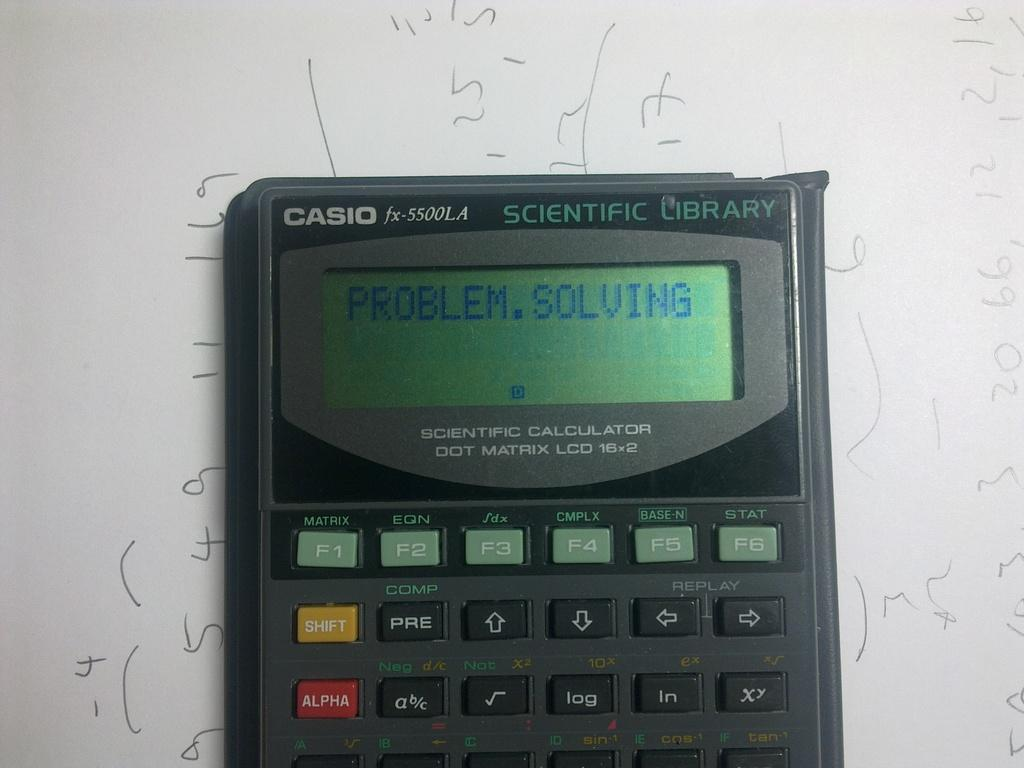Provide a one-sentence caption for the provided image. A Casio calculator says "Problem Solving" on the screen. 